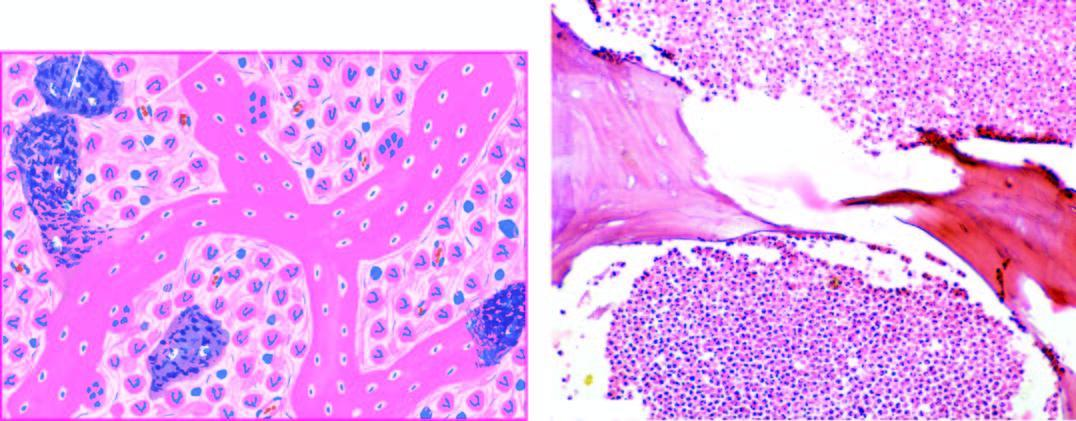does histologic appearance show necrotic bone and extensive purulent inflammatory exudate?
Answer the question using a single word or phrase. Yes 